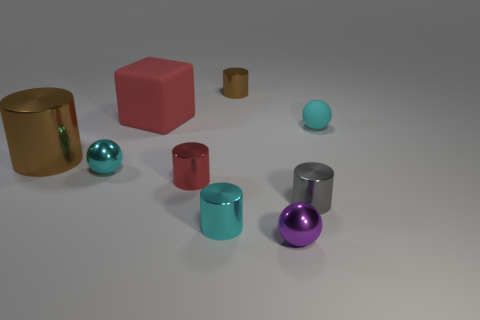Subtract all gray cylinders. How many cylinders are left? 4 Subtract all cyan cylinders. How many cylinders are left? 4 Subtract all yellow cylinders. Subtract all gray cubes. How many cylinders are left? 5 Add 1 tiny brown blocks. How many objects exist? 10 Subtract all cubes. How many objects are left? 8 Add 2 large rubber blocks. How many large rubber blocks are left? 3 Add 3 tiny gray matte cylinders. How many tiny gray matte cylinders exist? 3 Subtract 1 gray cylinders. How many objects are left? 8 Subtract all big shiny cylinders. Subtract all gray cylinders. How many objects are left? 7 